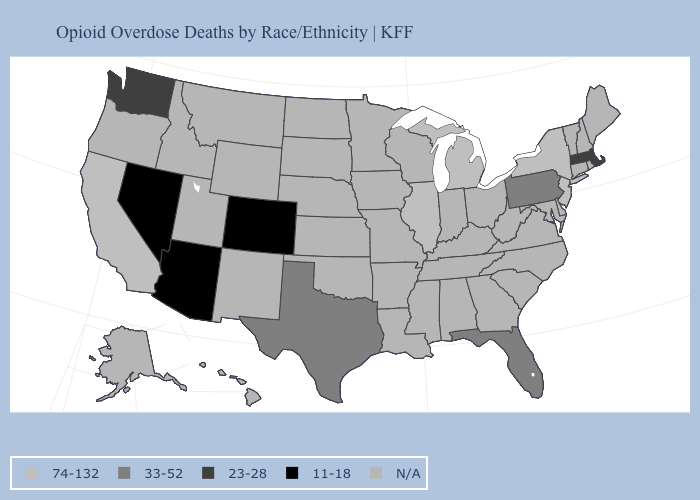Which states hav the highest value in the Northeast?
Keep it brief. New Jersey, New York. Name the states that have a value in the range 23-28?
Write a very short answer. Massachusetts, Washington. Which states have the lowest value in the MidWest?
Short answer required. Illinois, Michigan. Name the states that have a value in the range 33-52?
Write a very short answer. Florida, Pennsylvania, Texas. What is the value of Texas?
Give a very brief answer. 33-52. What is the value of Arizona?
Give a very brief answer. 11-18. Name the states that have a value in the range N/A?
Concise answer only. Alabama, Alaska, Arkansas, Connecticut, Delaware, Georgia, Hawaii, Idaho, Indiana, Iowa, Kansas, Kentucky, Louisiana, Maine, Maryland, Minnesota, Mississippi, Missouri, Montana, Nebraska, New Hampshire, New Mexico, North Carolina, North Dakota, Ohio, Oklahoma, Oregon, Rhode Island, South Carolina, South Dakota, Tennessee, Utah, Vermont, Virginia, West Virginia, Wisconsin, Wyoming. Is the legend a continuous bar?
Quick response, please. No. What is the value of New Jersey?
Give a very brief answer. 74-132. Name the states that have a value in the range 23-28?
Quick response, please. Massachusetts, Washington. Does the first symbol in the legend represent the smallest category?
Answer briefly. No. Which states have the lowest value in the USA?
Keep it brief. Arizona, Colorado, Nevada. What is the lowest value in the South?
Answer briefly. 33-52. Name the states that have a value in the range 11-18?
Concise answer only. Arizona, Colorado, Nevada. 